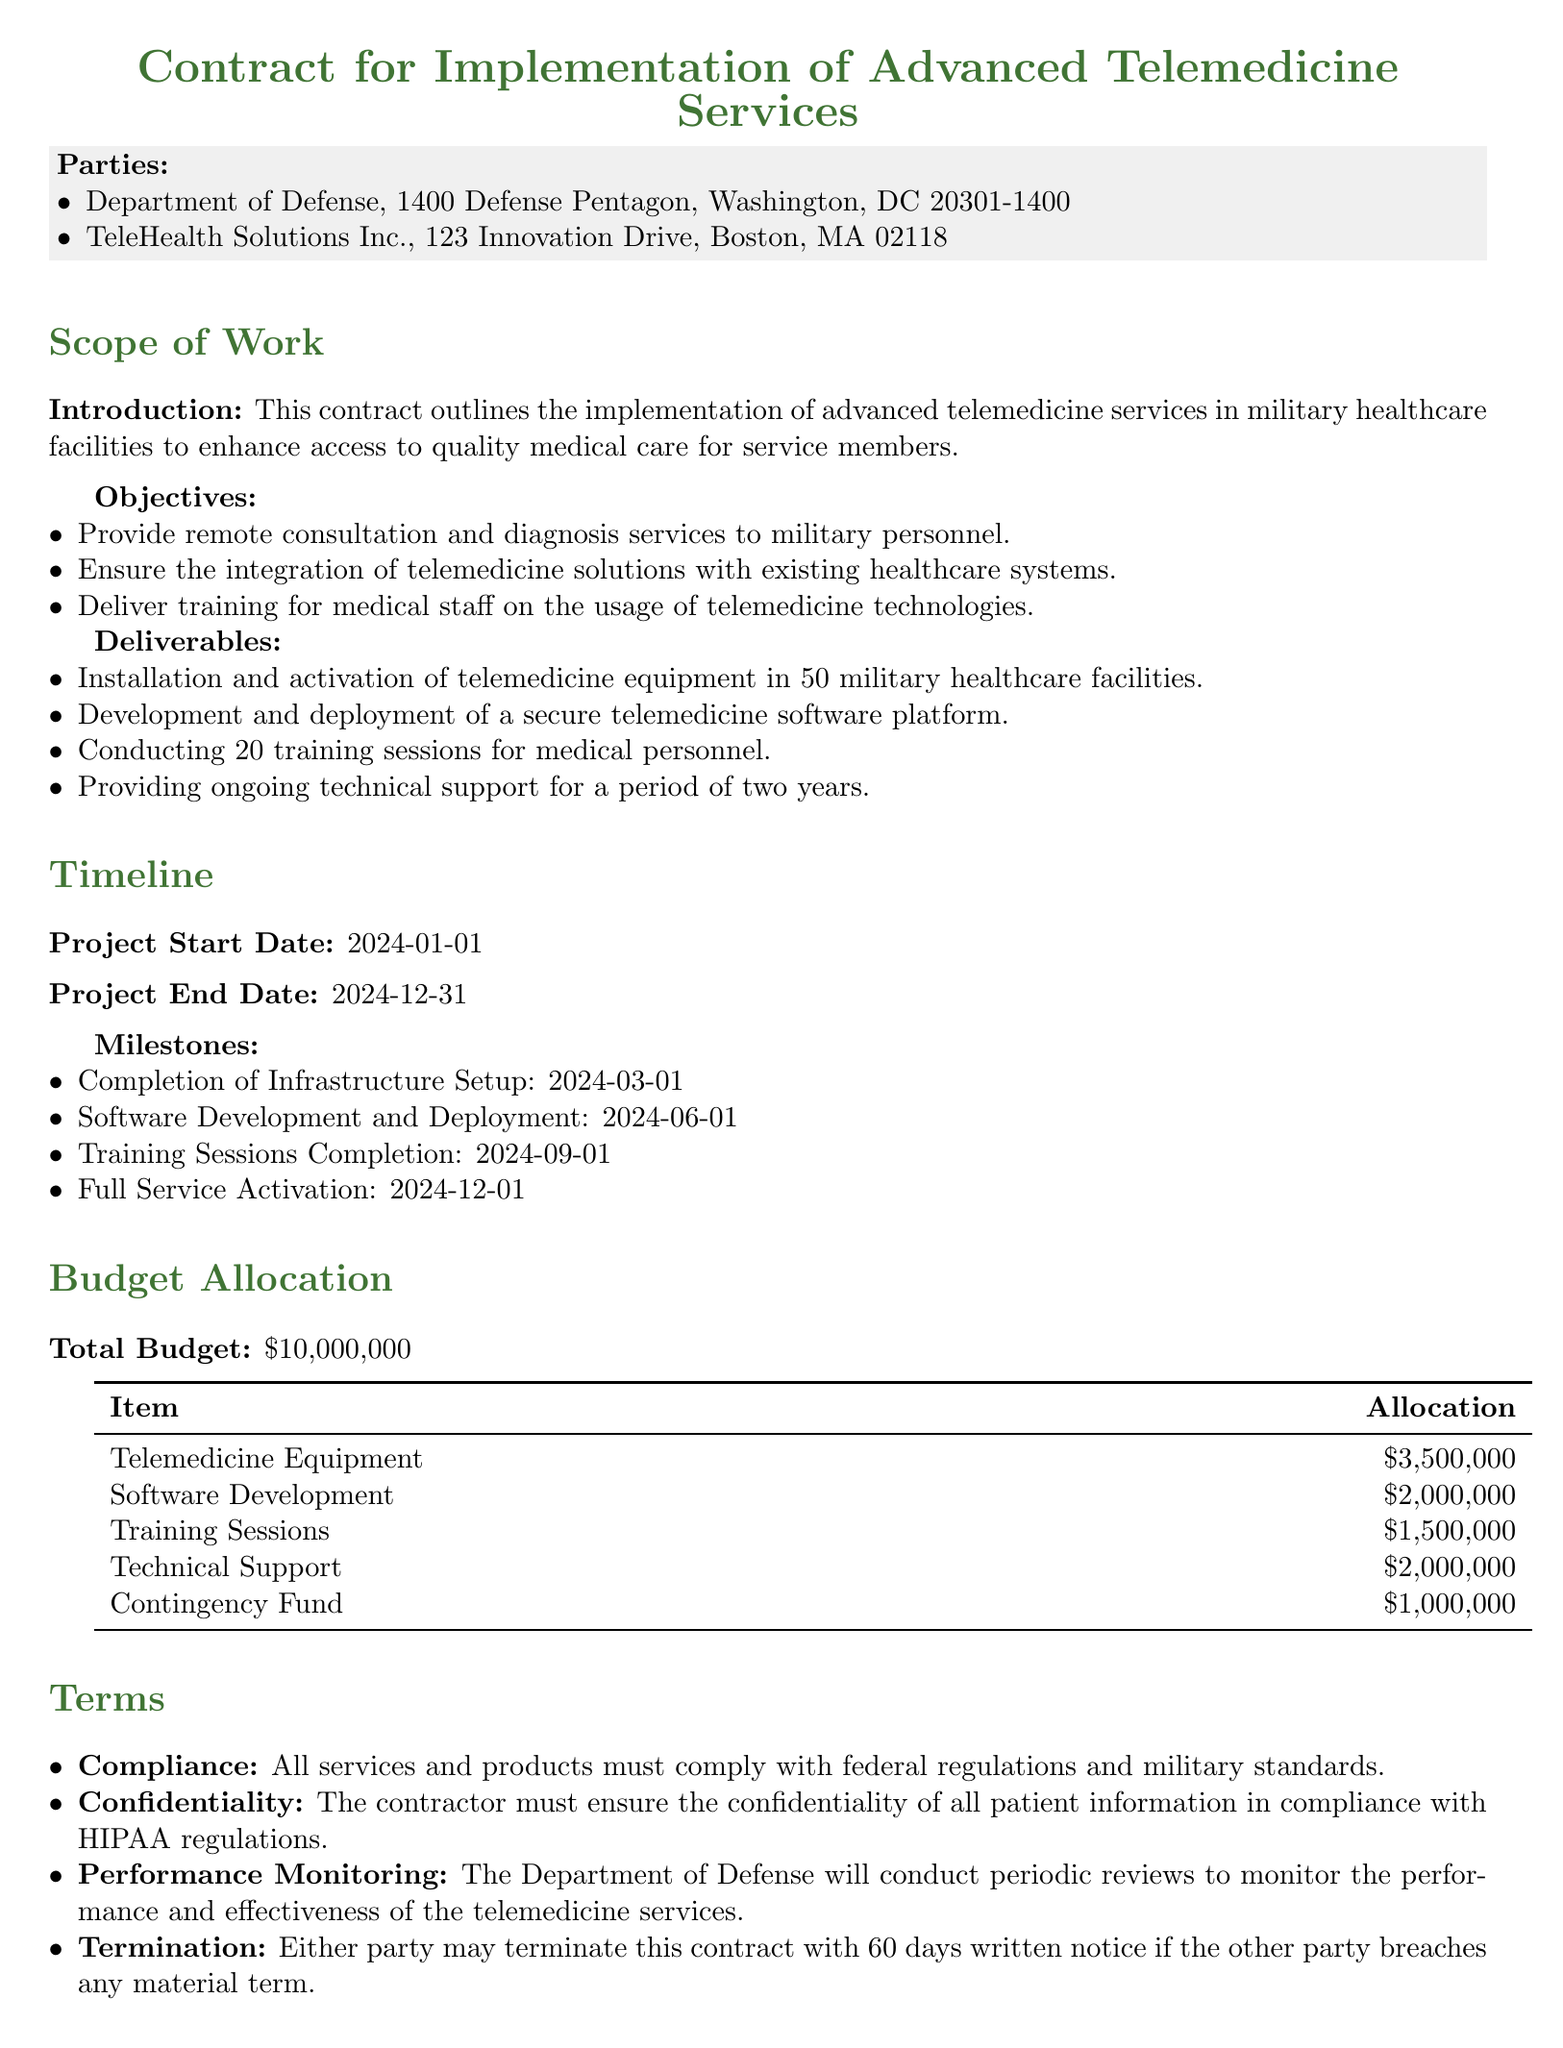What is the total budget for the telemedicine services? The total budget for the telemedicine services is specifically mentioned in the budget allocation section of the contract.
Answer: $10,000,000 When is the project start date? The project start date is indicated in the timeline section, providing a specific date of commencement.
Answer: 2024-01-01 How many training sessions will be conducted for medical personnel? The number of training sessions is listed under the deliverables section as a part of the contract obligations.
Answer: 20 Who are the parties involved in this contract? The parties to the contract are explicitly stated at the beginning of the document, outlining the organizations involved.
Answer: Department of Defense, TeleHealth Solutions Inc What is the scheduled completion date for infrastructure setup? The completion date for infrastructure setup is found in the list of milestones under the timeline section.
Answer: 2024-03-01 What is the allocation for telemedicine equipment? The allocation for telemedicine equipment is detailed in the budget allocation table, specifying the financial resources dedicated to this item.
Answer: $3,500,000 What are the confidentiality requirements mentioned in the terms? The terms section specifies compliance with HIPAA regulations as a requirement for confidentiality regarding patient information.
Answer: HIPAA regulations What is the project end date? The project end date is clearly provided in the timeline section, marking when the project is expected to be completed.
Answer: 2024-12-31 What is the consequence of a material breach according to the contract? The document details the termination conditions, specifically how a breach affects the contract relationship.
Answer: Termination with 60 days written notice 